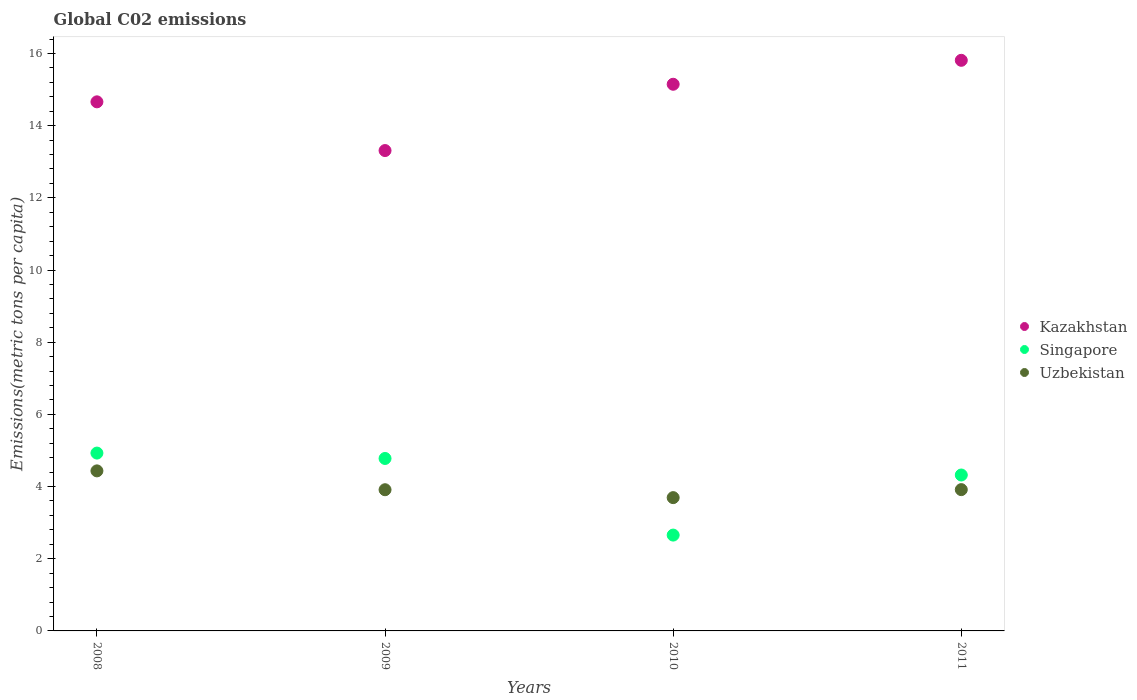How many different coloured dotlines are there?
Your answer should be very brief. 3. Is the number of dotlines equal to the number of legend labels?
Offer a very short reply. Yes. What is the amount of CO2 emitted in in Uzbekistan in 2010?
Your answer should be compact. 3.69. Across all years, what is the maximum amount of CO2 emitted in in Singapore?
Your answer should be very brief. 4.93. Across all years, what is the minimum amount of CO2 emitted in in Uzbekistan?
Your answer should be compact. 3.69. In which year was the amount of CO2 emitted in in Kazakhstan minimum?
Give a very brief answer. 2009. What is the total amount of CO2 emitted in in Singapore in the graph?
Provide a short and direct response. 16.68. What is the difference between the amount of CO2 emitted in in Uzbekistan in 2010 and that in 2011?
Your answer should be compact. -0.22. What is the difference between the amount of CO2 emitted in in Singapore in 2008 and the amount of CO2 emitted in in Kazakhstan in 2010?
Provide a short and direct response. -10.22. What is the average amount of CO2 emitted in in Kazakhstan per year?
Keep it short and to the point. 14.73. In the year 2011, what is the difference between the amount of CO2 emitted in in Kazakhstan and amount of CO2 emitted in in Uzbekistan?
Your answer should be compact. 11.9. In how many years, is the amount of CO2 emitted in in Singapore greater than 11.6 metric tons per capita?
Offer a terse response. 0. What is the ratio of the amount of CO2 emitted in in Singapore in 2008 to that in 2011?
Your response must be concise. 1.14. Is the amount of CO2 emitted in in Uzbekistan in 2009 less than that in 2011?
Make the answer very short. Yes. Is the difference between the amount of CO2 emitted in in Kazakhstan in 2008 and 2011 greater than the difference between the amount of CO2 emitted in in Uzbekistan in 2008 and 2011?
Give a very brief answer. No. What is the difference between the highest and the second highest amount of CO2 emitted in in Kazakhstan?
Keep it short and to the point. 0.66. What is the difference between the highest and the lowest amount of CO2 emitted in in Kazakhstan?
Your answer should be very brief. 2.5. Is the sum of the amount of CO2 emitted in in Kazakhstan in 2009 and 2011 greater than the maximum amount of CO2 emitted in in Singapore across all years?
Your answer should be very brief. Yes. Is the amount of CO2 emitted in in Uzbekistan strictly less than the amount of CO2 emitted in in Kazakhstan over the years?
Your response must be concise. Yes. Does the graph contain any zero values?
Provide a succinct answer. No. Does the graph contain grids?
Your answer should be very brief. No. How many legend labels are there?
Offer a very short reply. 3. What is the title of the graph?
Your response must be concise. Global C02 emissions. Does "Marshall Islands" appear as one of the legend labels in the graph?
Make the answer very short. No. What is the label or title of the Y-axis?
Keep it short and to the point. Emissions(metric tons per capita). What is the Emissions(metric tons per capita) of Kazakhstan in 2008?
Your answer should be very brief. 14.66. What is the Emissions(metric tons per capita) of Singapore in 2008?
Ensure brevity in your answer.  4.93. What is the Emissions(metric tons per capita) of Uzbekistan in 2008?
Your response must be concise. 4.43. What is the Emissions(metric tons per capita) in Kazakhstan in 2009?
Ensure brevity in your answer.  13.31. What is the Emissions(metric tons per capita) of Singapore in 2009?
Ensure brevity in your answer.  4.78. What is the Emissions(metric tons per capita) in Uzbekistan in 2009?
Keep it short and to the point. 3.91. What is the Emissions(metric tons per capita) in Kazakhstan in 2010?
Provide a succinct answer. 15.15. What is the Emissions(metric tons per capita) of Singapore in 2010?
Your answer should be very brief. 2.66. What is the Emissions(metric tons per capita) of Uzbekistan in 2010?
Keep it short and to the point. 3.69. What is the Emissions(metric tons per capita) in Kazakhstan in 2011?
Your response must be concise. 15.81. What is the Emissions(metric tons per capita) of Singapore in 2011?
Provide a short and direct response. 4.32. What is the Emissions(metric tons per capita) of Uzbekistan in 2011?
Give a very brief answer. 3.91. Across all years, what is the maximum Emissions(metric tons per capita) of Kazakhstan?
Your response must be concise. 15.81. Across all years, what is the maximum Emissions(metric tons per capita) of Singapore?
Make the answer very short. 4.93. Across all years, what is the maximum Emissions(metric tons per capita) of Uzbekistan?
Make the answer very short. 4.43. Across all years, what is the minimum Emissions(metric tons per capita) in Kazakhstan?
Your response must be concise. 13.31. Across all years, what is the minimum Emissions(metric tons per capita) of Singapore?
Make the answer very short. 2.66. Across all years, what is the minimum Emissions(metric tons per capita) in Uzbekistan?
Your answer should be compact. 3.69. What is the total Emissions(metric tons per capita) of Kazakhstan in the graph?
Ensure brevity in your answer.  58.93. What is the total Emissions(metric tons per capita) in Singapore in the graph?
Your answer should be very brief. 16.68. What is the total Emissions(metric tons per capita) in Uzbekistan in the graph?
Ensure brevity in your answer.  15.95. What is the difference between the Emissions(metric tons per capita) in Kazakhstan in 2008 and that in 2009?
Offer a terse response. 1.35. What is the difference between the Emissions(metric tons per capita) of Singapore in 2008 and that in 2009?
Provide a short and direct response. 0.15. What is the difference between the Emissions(metric tons per capita) of Uzbekistan in 2008 and that in 2009?
Your answer should be very brief. 0.52. What is the difference between the Emissions(metric tons per capita) of Kazakhstan in 2008 and that in 2010?
Ensure brevity in your answer.  -0.49. What is the difference between the Emissions(metric tons per capita) in Singapore in 2008 and that in 2010?
Your response must be concise. 2.27. What is the difference between the Emissions(metric tons per capita) in Uzbekistan in 2008 and that in 2010?
Offer a terse response. 0.74. What is the difference between the Emissions(metric tons per capita) of Kazakhstan in 2008 and that in 2011?
Give a very brief answer. -1.15. What is the difference between the Emissions(metric tons per capita) of Singapore in 2008 and that in 2011?
Provide a succinct answer. 0.61. What is the difference between the Emissions(metric tons per capita) in Uzbekistan in 2008 and that in 2011?
Your answer should be very brief. 0.52. What is the difference between the Emissions(metric tons per capita) of Kazakhstan in 2009 and that in 2010?
Offer a terse response. -1.84. What is the difference between the Emissions(metric tons per capita) of Singapore in 2009 and that in 2010?
Ensure brevity in your answer.  2.12. What is the difference between the Emissions(metric tons per capita) of Uzbekistan in 2009 and that in 2010?
Keep it short and to the point. 0.22. What is the difference between the Emissions(metric tons per capita) in Kazakhstan in 2009 and that in 2011?
Your answer should be compact. -2.5. What is the difference between the Emissions(metric tons per capita) in Singapore in 2009 and that in 2011?
Give a very brief answer. 0.46. What is the difference between the Emissions(metric tons per capita) in Uzbekistan in 2009 and that in 2011?
Make the answer very short. -0. What is the difference between the Emissions(metric tons per capita) in Kazakhstan in 2010 and that in 2011?
Your response must be concise. -0.66. What is the difference between the Emissions(metric tons per capita) of Singapore in 2010 and that in 2011?
Your answer should be very brief. -1.66. What is the difference between the Emissions(metric tons per capita) in Uzbekistan in 2010 and that in 2011?
Offer a very short reply. -0.22. What is the difference between the Emissions(metric tons per capita) of Kazakhstan in 2008 and the Emissions(metric tons per capita) of Singapore in 2009?
Provide a succinct answer. 9.88. What is the difference between the Emissions(metric tons per capita) of Kazakhstan in 2008 and the Emissions(metric tons per capita) of Uzbekistan in 2009?
Provide a succinct answer. 10.75. What is the difference between the Emissions(metric tons per capita) of Singapore in 2008 and the Emissions(metric tons per capita) of Uzbekistan in 2009?
Keep it short and to the point. 1.02. What is the difference between the Emissions(metric tons per capita) of Kazakhstan in 2008 and the Emissions(metric tons per capita) of Singapore in 2010?
Your answer should be very brief. 12. What is the difference between the Emissions(metric tons per capita) of Kazakhstan in 2008 and the Emissions(metric tons per capita) of Uzbekistan in 2010?
Provide a short and direct response. 10.97. What is the difference between the Emissions(metric tons per capita) in Singapore in 2008 and the Emissions(metric tons per capita) in Uzbekistan in 2010?
Your answer should be compact. 1.23. What is the difference between the Emissions(metric tons per capita) of Kazakhstan in 2008 and the Emissions(metric tons per capita) of Singapore in 2011?
Give a very brief answer. 10.34. What is the difference between the Emissions(metric tons per capita) in Kazakhstan in 2008 and the Emissions(metric tons per capita) in Uzbekistan in 2011?
Offer a very short reply. 10.74. What is the difference between the Emissions(metric tons per capita) of Singapore in 2008 and the Emissions(metric tons per capita) of Uzbekistan in 2011?
Your answer should be compact. 1.01. What is the difference between the Emissions(metric tons per capita) in Kazakhstan in 2009 and the Emissions(metric tons per capita) in Singapore in 2010?
Offer a terse response. 10.65. What is the difference between the Emissions(metric tons per capita) in Kazakhstan in 2009 and the Emissions(metric tons per capita) in Uzbekistan in 2010?
Provide a short and direct response. 9.62. What is the difference between the Emissions(metric tons per capita) of Singapore in 2009 and the Emissions(metric tons per capita) of Uzbekistan in 2010?
Provide a succinct answer. 1.08. What is the difference between the Emissions(metric tons per capita) in Kazakhstan in 2009 and the Emissions(metric tons per capita) in Singapore in 2011?
Give a very brief answer. 8.99. What is the difference between the Emissions(metric tons per capita) of Kazakhstan in 2009 and the Emissions(metric tons per capita) of Uzbekistan in 2011?
Your answer should be compact. 9.39. What is the difference between the Emissions(metric tons per capita) in Singapore in 2009 and the Emissions(metric tons per capita) in Uzbekistan in 2011?
Provide a succinct answer. 0.86. What is the difference between the Emissions(metric tons per capita) of Kazakhstan in 2010 and the Emissions(metric tons per capita) of Singapore in 2011?
Your response must be concise. 10.83. What is the difference between the Emissions(metric tons per capita) in Kazakhstan in 2010 and the Emissions(metric tons per capita) in Uzbekistan in 2011?
Ensure brevity in your answer.  11.23. What is the difference between the Emissions(metric tons per capita) of Singapore in 2010 and the Emissions(metric tons per capita) of Uzbekistan in 2011?
Make the answer very short. -1.26. What is the average Emissions(metric tons per capita) in Kazakhstan per year?
Keep it short and to the point. 14.73. What is the average Emissions(metric tons per capita) of Singapore per year?
Offer a terse response. 4.17. What is the average Emissions(metric tons per capita) of Uzbekistan per year?
Your answer should be very brief. 3.99. In the year 2008, what is the difference between the Emissions(metric tons per capita) in Kazakhstan and Emissions(metric tons per capita) in Singapore?
Your answer should be very brief. 9.73. In the year 2008, what is the difference between the Emissions(metric tons per capita) in Kazakhstan and Emissions(metric tons per capita) in Uzbekistan?
Give a very brief answer. 10.23. In the year 2008, what is the difference between the Emissions(metric tons per capita) of Singapore and Emissions(metric tons per capita) of Uzbekistan?
Provide a short and direct response. 0.49. In the year 2009, what is the difference between the Emissions(metric tons per capita) in Kazakhstan and Emissions(metric tons per capita) in Singapore?
Make the answer very short. 8.53. In the year 2009, what is the difference between the Emissions(metric tons per capita) of Kazakhstan and Emissions(metric tons per capita) of Uzbekistan?
Provide a short and direct response. 9.4. In the year 2009, what is the difference between the Emissions(metric tons per capita) of Singapore and Emissions(metric tons per capita) of Uzbekistan?
Your response must be concise. 0.87. In the year 2010, what is the difference between the Emissions(metric tons per capita) of Kazakhstan and Emissions(metric tons per capita) of Singapore?
Your response must be concise. 12.49. In the year 2010, what is the difference between the Emissions(metric tons per capita) in Kazakhstan and Emissions(metric tons per capita) in Uzbekistan?
Make the answer very short. 11.45. In the year 2010, what is the difference between the Emissions(metric tons per capita) in Singapore and Emissions(metric tons per capita) in Uzbekistan?
Your answer should be compact. -1.04. In the year 2011, what is the difference between the Emissions(metric tons per capita) of Kazakhstan and Emissions(metric tons per capita) of Singapore?
Your answer should be very brief. 11.49. In the year 2011, what is the difference between the Emissions(metric tons per capita) in Kazakhstan and Emissions(metric tons per capita) in Uzbekistan?
Your response must be concise. 11.9. In the year 2011, what is the difference between the Emissions(metric tons per capita) in Singapore and Emissions(metric tons per capita) in Uzbekistan?
Your answer should be very brief. 0.41. What is the ratio of the Emissions(metric tons per capita) of Kazakhstan in 2008 to that in 2009?
Your response must be concise. 1.1. What is the ratio of the Emissions(metric tons per capita) of Singapore in 2008 to that in 2009?
Ensure brevity in your answer.  1.03. What is the ratio of the Emissions(metric tons per capita) in Uzbekistan in 2008 to that in 2009?
Offer a terse response. 1.13. What is the ratio of the Emissions(metric tons per capita) of Kazakhstan in 2008 to that in 2010?
Give a very brief answer. 0.97. What is the ratio of the Emissions(metric tons per capita) in Singapore in 2008 to that in 2010?
Offer a terse response. 1.86. What is the ratio of the Emissions(metric tons per capita) of Uzbekistan in 2008 to that in 2010?
Give a very brief answer. 1.2. What is the ratio of the Emissions(metric tons per capita) in Kazakhstan in 2008 to that in 2011?
Provide a succinct answer. 0.93. What is the ratio of the Emissions(metric tons per capita) of Singapore in 2008 to that in 2011?
Keep it short and to the point. 1.14. What is the ratio of the Emissions(metric tons per capita) in Uzbekistan in 2008 to that in 2011?
Offer a very short reply. 1.13. What is the ratio of the Emissions(metric tons per capita) in Kazakhstan in 2009 to that in 2010?
Provide a short and direct response. 0.88. What is the ratio of the Emissions(metric tons per capita) of Singapore in 2009 to that in 2010?
Give a very brief answer. 1.8. What is the ratio of the Emissions(metric tons per capita) in Uzbekistan in 2009 to that in 2010?
Give a very brief answer. 1.06. What is the ratio of the Emissions(metric tons per capita) in Kazakhstan in 2009 to that in 2011?
Make the answer very short. 0.84. What is the ratio of the Emissions(metric tons per capita) of Singapore in 2009 to that in 2011?
Offer a very short reply. 1.11. What is the ratio of the Emissions(metric tons per capita) of Kazakhstan in 2010 to that in 2011?
Your answer should be compact. 0.96. What is the ratio of the Emissions(metric tons per capita) of Singapore in 2010 to that in 2011?
Keep it short and to the point. 0.61. What is the ratio of the Emissions(metric tons per capita) in Uzbekistan in 2010 to that in 2011?
Provide a succinct answer. 0.94. What is the difference between the highest and the second highest Emissions(metric tons per capita) of Kazakhstan?
Ensure brevity in your answer.  0.66. What is the difference between the highest and the second highest Emissions(metric tons per capita) in Singapore?
Your response must be concise. 0.15. What is the difference between the highest and the second highest Emissions(metric tons per capita) of Uzbekistan?
Ensure brevity in your answer.  0.52. What is the difference between the highest and the lowest Emissions(metric tons per capita) of Kazakhstan?
Keep it short and to the point. 2.5. What is the difference between the highest and the lowest Emissions(metric tons per capita) of Singapore?
Offer a terse response. 2.27. What is the difference between the highest and the lowest Emissions(metric tons per capita) of Uzbekistan?
Offer a very short reply. 0.74. 